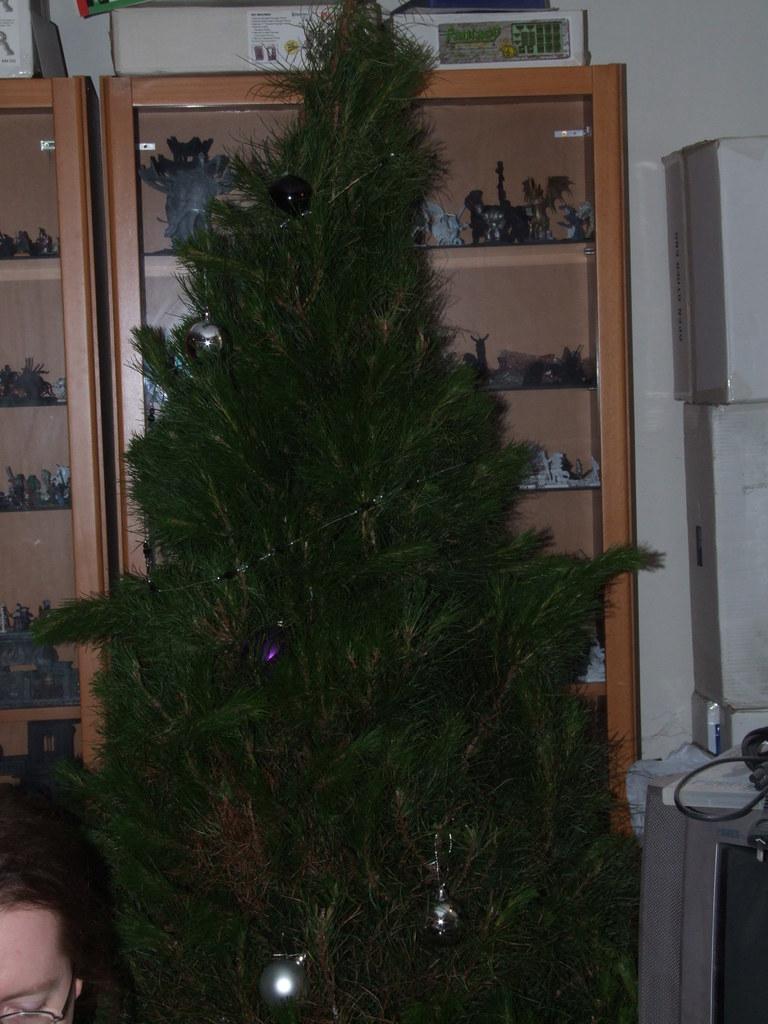In one or two sentences, can you explain what this image depicts? In this image we can see a Christmas tree. In the background there are cupboards with objects in the rows of them, walls and a television set. There is a woman beside the Christmas tree. 